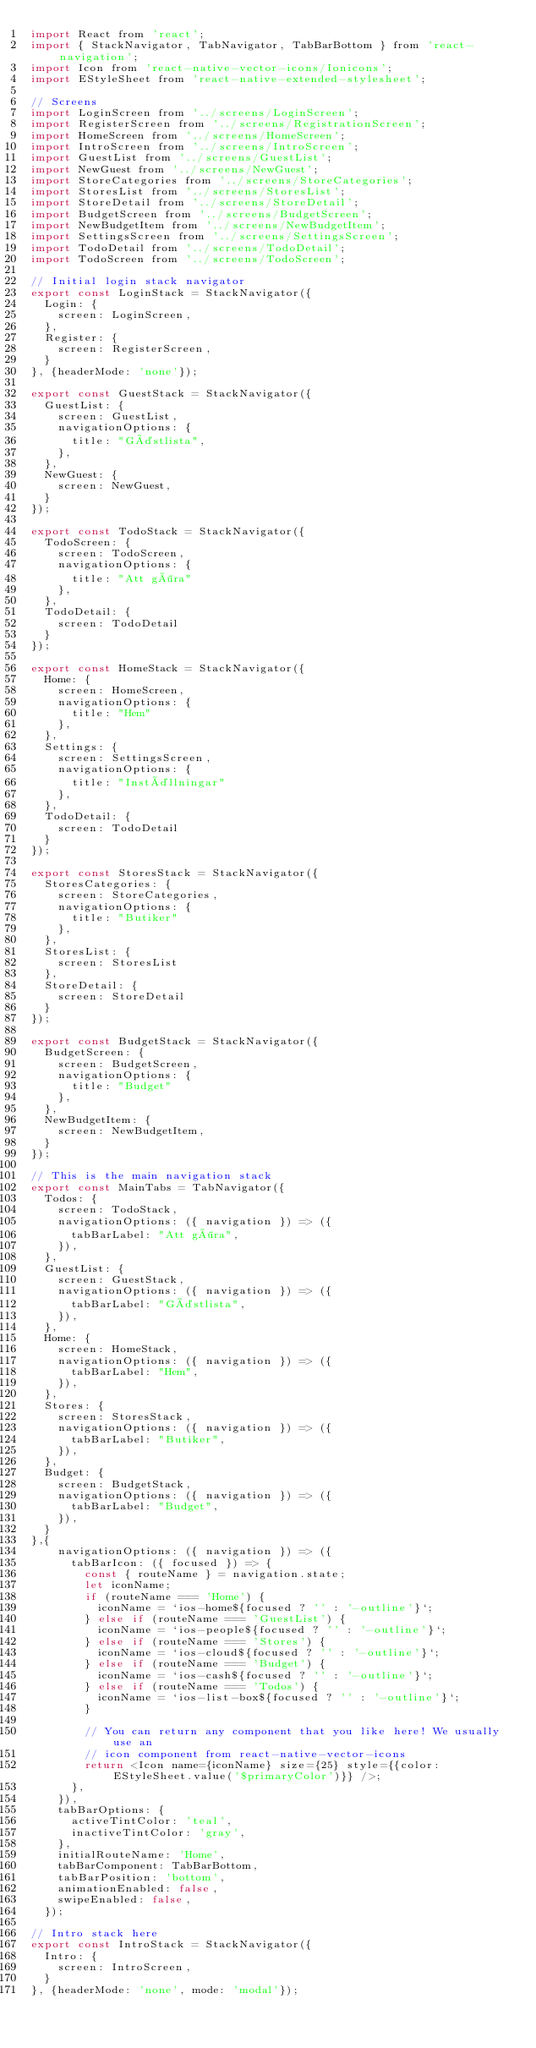<code> <loc_0><loc_0><loc_500><loc_500><_JavaScript_>import React from 'react';
import { StackNavigator, TabNavigator, TabBarBottom } from 'react-navigation';
import Icon from 'react-native-vector-icons/Ionicons';
import EStyleSheet from 'react-native-extended-stylesheet';

// Screens
import LoginScreen from '../screens/LoginScreen';
import RegisterScreen from '../screens/RegistrationScreen';
import HomeScreen from '../screens/HomeScreen';
import IntroScreen from '../screens/IntroScreen';
import GuestList from '../screens/GuestList';
import NewGuest from '../screens/NewGuest';
import StoreCategories from '../screens/StoreCategories';
import StoresList from '../screens/StoresList';
import StoreDetail from '../screens/StoreDetail';
import BudgetScreen from '../screens/BudgetScreen';
import NewBudgetItem from '../screens/NewBudgetItem';
import SettingsScreen from '../screens/SettingsScreen';
import TodoDetail from '../screens/TodoDetail';
import TodoScreen from '../screens/TodoScreen';

// Initial login stack navigator
export const LoginStack = StackNavigator({
  Login: {
    screen: LoginScreen,
  },
  Register: {
    screen: RegisterScreen,
  }
}, {headerMode: 'none'});

export const GuestStack = StackNavigator({
  GuestList: {
    screen: GuestList,
    navigationOptions: {
      title: "Gästlista",
    },
  },
  NewGuest: {
    screen: NewGuest,
  }
});

export const TodoStack = StackNavigator({
  TodoScreen: {
    screen: TodoScreen,
    navigationOptions: {
      title: "Att göra"
    },
  },
  TodoDetail: {
    screen: TodoDetail
  }
});

export const HomeStack = StackNavigator({
  Home: {
    screen: HomeScreen,
    navigationOptions: {
      title: "Hem"
    },
  },
  Settings: {
    screen: SettingsScreen,
    navigationOptions: {
      title: "Inställningar"
    },
  },
  TodoDetail: {
    screen: TodoDetail
  }
});

export const StoresStack = StackNavigator({
  StoresCategories: {
    screen: StoreCategories,
    navigationOptions: {
      title: "Butiker"
    },
  },
  StoresList: {
    screen: StoresList
  },
  StoreDetail: {
    screen: StoreDetail
  }
});

export const BudgetStack = StackNavigator({
  BudgetScreen: {
    screen: BudgetScreen,
    navigationOptions: {
      title: "Budget"
    },
  },
  NewBudgetItem: {
    screen: NewBudgetItem,
  }
});

// This is the main navigation stack
export const MainTabs = TabNavigator({
  Todos: {
    screen: TodoStack,
    navigationOptions: ({ navigation }) => ({
      tabBarLabel: "Att göra",
    }),
  },
  GuestList: {
    screen: GuestStack,
    navigationOptions: ({ navigation }) => ({
      tabBarLabel: "Gästlista",
    }),
  },
  Home: {
    screen: HomeStack,
    navigationOptions: ({ navigation }) => ({
      tabBarLabel: "Hem",
    }),
  },
  Stores: {
    screen: StoresStack,
    navigationOptions: ({ navigation }) => ({
      tabBarLabel: "Butiker",
    }),
  },
  Budget: {
    screen: BudgetStack,
    navigationOptions: ({ navigation }) => ({
      tabBarLabel: "Budget",
    }),
  }
},{
    navigationOptions: ({ navigation }) => ({
      tabBarIcon: ({ focused }) => {
        const { routeName } = navigation.state;
        let iconName;
        if (routeName === 'Home') {
          iconName = `ios-home${focused ? '' : '-outline'}`;
        } else if (routeName === 'GuestList') {
          iconName = `ios-people${focused ? '' : '-outline'}`;
        } else if (routeName === 'Stores') {
          iconName = `ios-cloud${focused ? '' : '-outline'}`;
        } else if (routeName === 'Budget') {
          iconName = `ios-cash${focused ? '' : '-outline'}`;
        } else if (routeName === 'Todos') {
          iconName = `ios-list-box${focused ? '' : '-outline'}`;
        }

        // You can return any component that you like here! We usually use an
        // icon component from react-native-vector-icons
        return <Icon name={iconName} size={25} style={{color: EStyleSheet.value('$primaryColor')}} />;
      },
    }),
    tabBarOptions: {
      activeTintColor: 'teal',
      inactiveTintColor: 'gray',
    },
    initialRouteName: 'Home',
    tabBarComponent: TabBarBottom,
    tabBarPosition: 'bottom',
    animationEnabled: false,
    swipeEnabled: false,
  });

// Intro stack here
export const IntroStack = StackNavigator({
  Intro: {
    screen: IntroScreen,
  }
}, {headerMode: 'none', mode: 'modal'});
</code> 